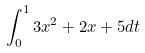Convert formula to latex. <formula><loc_0><loc_0><loc_500><loc_500>\int _ { 0 } ^ { 1 } 3 x ^ { 2 } + 2 x + 5 d t</formula> 